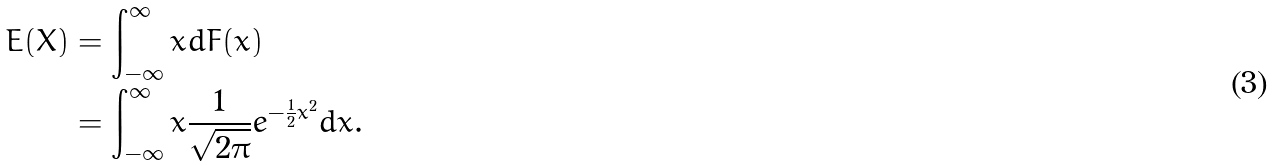Convert formula to latex. <formula><loc_0><loc_0><loc_500><loc_500>E ( X ) & = \int _ { - \infty } ^ { \infty } x d F ( x ) \\ & = \int _ { - \infty } ^ { \infty } x \frac { 1 } { \sqrt { 2 \pi } } e ^ { - \frac { 1 } { 2 } x ^ { 2 } } d x .</formula> 